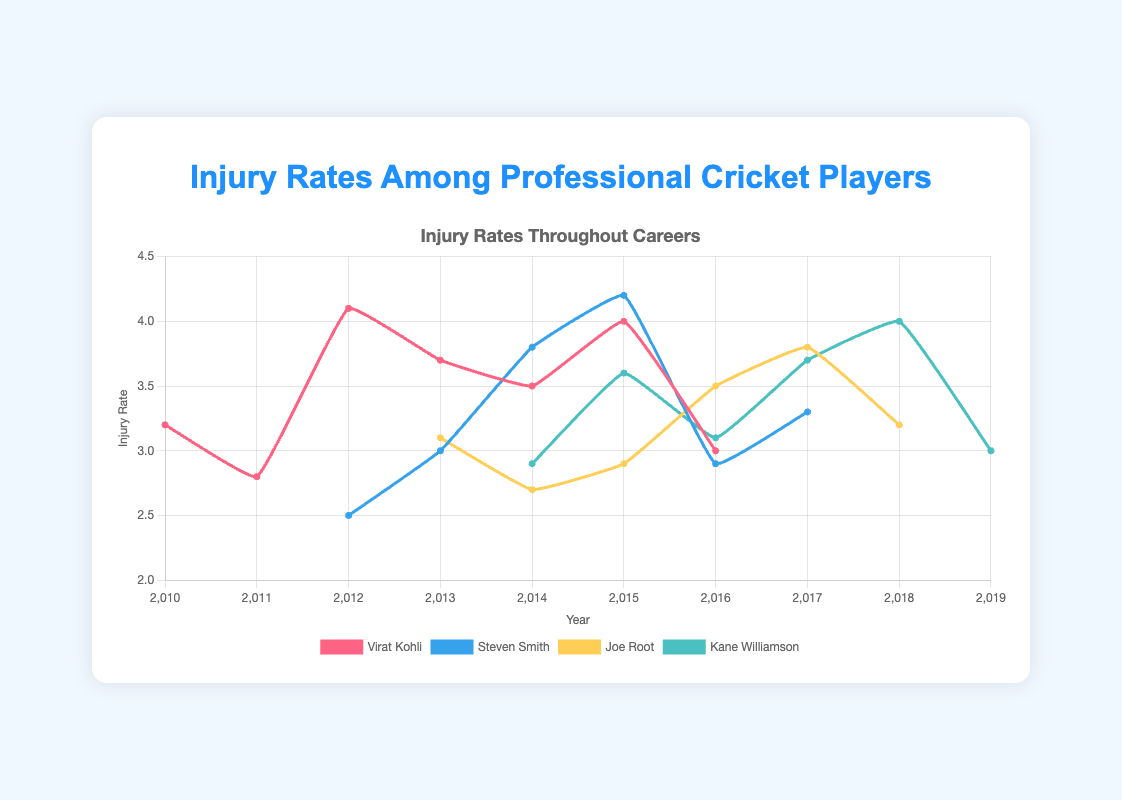Which player had the highest injury rate in 2015? Look at each player's line at the year 2015 and compare the heights. Steven Smith's line is the highest.
Answer: Steven Smith What is the average injury rate for Virat Kohli from 2010 to 2016? Sum Virat's injury rates from 2010 to 2016 (3.2 + 2.8 + 4.1 + 3.7 + 3.5 + 4.0 + 3.0) = 24.3 and divide by 7 (number of years) = 24.3 / 7
Answer: 3.47 In which year did Joe Root have the lowest recorded injury rate? Look at Joe Root's line and find the lowest point. The year corresponding to the lowest point is 2014 with a rate of 2.7
Answer: 2014 Compare the injury rate trends between Kane Williamson and Joe Root between 2014 and 2017. Who had a more consistent trend? Kane starts at 2.9 and goes up and down, higher alternately. Joe Root goes from 2.7 to 3.8 almost in an increasing trend.
Answer: Joe Root What is the difference in injury rates between Steven Smith and Kane Williamson in 2015? Subtract Kane's rate from Steven's: 4.2 (Steven) - 3.6 (Kane) = 0.6
Answer: 0.6 Which player shows a declining trend in injury rates from 2014 to 2016? Look for players which each subsequent year has a lower rate between 2014 and 2016. Both Kane Williamson (3.6 -> 3.1 -> 3.7) and Virat Kohli (3.5 -> 3.0) don't have a steady decline. Joe Root shows an increase (3.1 -> 2.7 -> 2.9).
Answer: None Between 2010 and 2013, what was the highest injury rate recorded by Virat Kohli? Check Virat's injury rates each year from 2010 to 2013 and find the highest: 3.2, 2.8, 4.1, 3.7. The highest is 4.1 in 2012.
Answer: 4.1 How many years did Steven Smith maintain an injury rate below 3? Check Steven Smith's injury rate each year and count the years below 3: 2012 (2.5), 2013 (3.0), 2016 (2.9)
Answer: 2 Which player had the highest injury rate in 2017? Look at each player's injury rate in 2017 and find the highest. Joe Root at 3.8.
Answer: Joe Root 